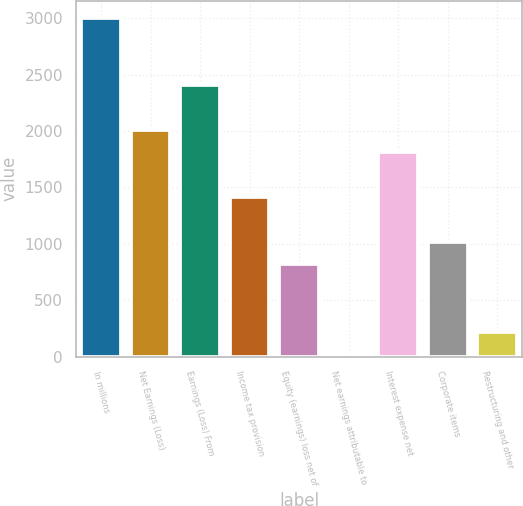<chart> <loc_0><loc_0><loc_500><loc_500><bar_chart><fcel>In millions<fcel>Net Earnings (Loss)<fcel>Earnings (Loss) From<fcel>Income tax provision<fcel>Equity (earnings) loss net of<fcel>Net earnings attributable to<fcel>Interest expense net<fcel>Corporate items<fcel>Restructuring and other<nl><fcel>3004.5<fcel>2010<fcel>2407.8<fcel>1413.3<fcel>816.6<fcel>21<fcel>1811.1<fcel>1015.5<fcel>219.9<nl></chart> 